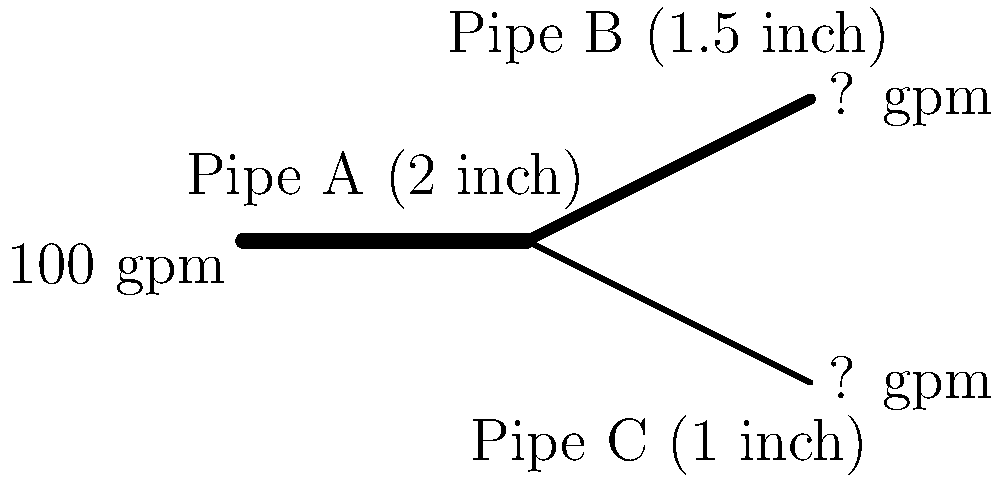In your local water distribution system, a 2-inch main pipe (Pipe A) splits into two smaller pipes: Pipe B (1.5 inches) and Pipe C (1 inch). If the flow rate in Pipe A is 100 gallons per minute (gpm), what is the flow rate in Pipe C, assuming the flow is proportional to the cross-sectional area of each pipe? Let's approach this step-by-step:

1) First, we need to calculate the cross-sectional areas of each pipe:
   
   Pipe A: $A_A = \pi r_A^2 = \pi (1 \text{ inch})^2 = \pi \text{ sq inches}$
   Pipe B: $A_B = \pi r_B^2 = \pi (0.75 \text{ inch})^2 = 0.5625\pi \text{ sq inches}$
   Pipe C: $A_C = \pi r_C^2 = \pi (0.5 \text{ inch})^2 = 0.25\pi \text{ sq inches}$

2) The total area of pipes B and C should equal the area of pipe A:
   
   $A_A = A_B + A_C$
   $\pi = 0.5625\pi + 0.25\pi$

3) The flow rate is proportional to the cross-sectional area. Let's call the flow rates $Q_A$, $Q_B$, and $Q_C$:
   
   $\frac{Q_A}{A_A} = \frac{Q_B}{A_B} = \frac{Q_C}{A_C}$

4) We know that $Q_A = 100 \text{ gpm}$ and $Q_A = Q_B + Q_C$

5) The proportion of flow in pipe C will be:
   
   $\frac{Q_C}{Q_A} = \frac{A_C}{A_A} = \frac{0.25\pi}{\pi} = 0.25$

6) Therefore, the flow rate in pipe C is:
   
   $Q_C = 0.25 \times 100 \text{ gpm} = 25 \text{ gpm}$
Answer: 25 gpm 